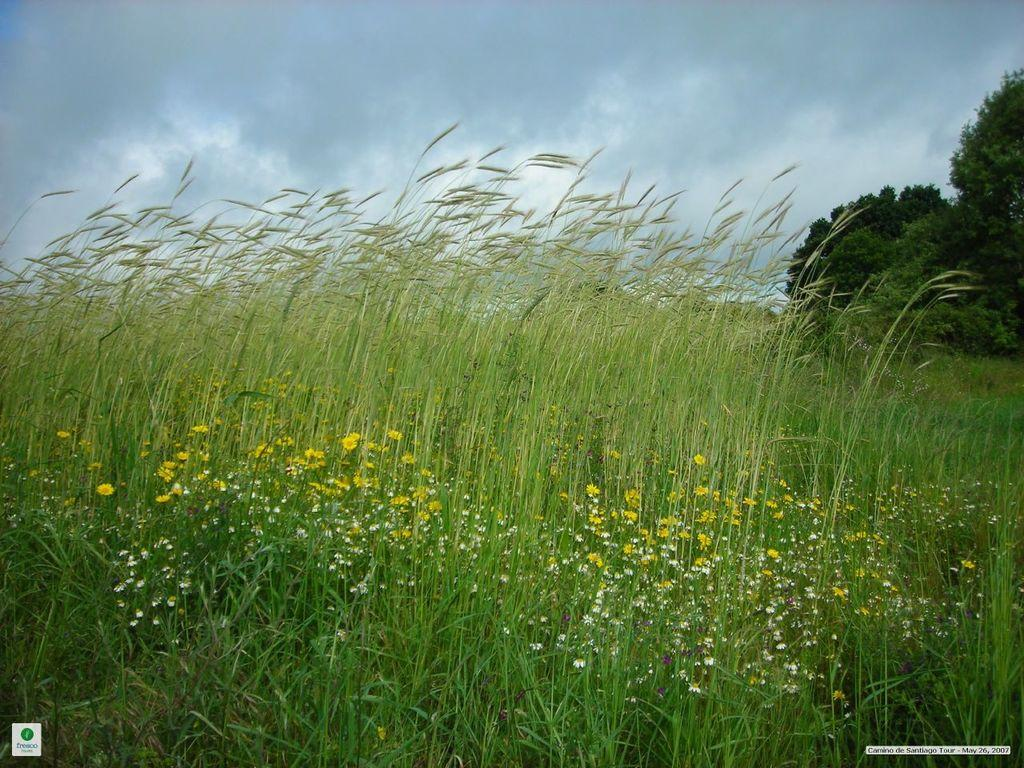What type of vegetation can be seen in the image? There is grass and flowers in the image. What can be seen in the background of the image? There are trees and the sky visible in the background of the image. What type of skate is being used by the daughter in the image? There is no daughter or skate present in the image. How does the sand appear in the image? There is no sand present in the image. 